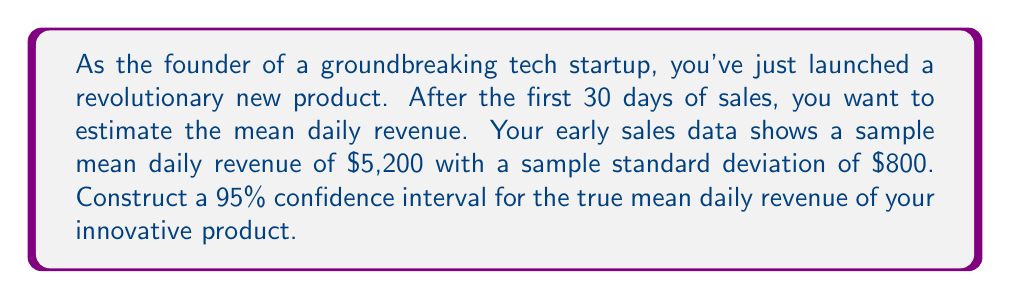Provide a solution to this math problem. To construct a confidence interval for the mean revenue, we'll follow these steps:

1. Identify the known values:
   - Sample size: $n = 30$
   - Sample mean: $\bar{x} = \$5,200$
   - Sample standard deviation: $s = \$800$
   - Confidence level: 95% (α = 0.05)

2. Determine the critical value:
   For a 95% confidence interval with 29 degrees of freedom (n-1), we use the t-distribution. The critical value is $t_{0.025, 29} = 2.045$ (from t-table or calculator).

3. Calculate the margin of error:
   Margin of error = $t_{0.025, 29} \cdot \frac{s}{\sqrt{n}}$
   $$ \text{Margin of error} = 2.045 \cdot \frac{800}{\sqrt{30}} = 2.045 \cdot 146.06 = 298.69 $$

4. Construct the confidence interval:
   CI = $(\bar{x} - \text{Margin of error}, \bar{x} + \text{Margin of error})$
   $$ \text{CI} = (5200 - 298.69, 5200 + 298.69) $$
   $$ \text{CI} = (4901.31, 5498.69) $$

5. Round to the nearest dollar:
   $$ \text{CI} = (\$4,901, \$5,499) $$

This interval suggests that we can be 95% confident that the true mean daily revenue for your innovative product falls between $4,901 and $5,499.
Answer: 95% CI: ($4,901, $5,499) 